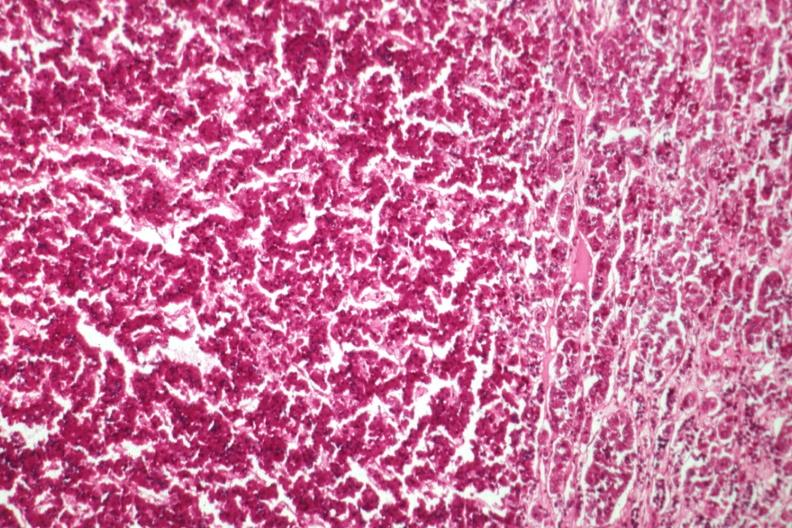what is present?
Answer the question using a single word or phrase. Eosinophilic adenoma 